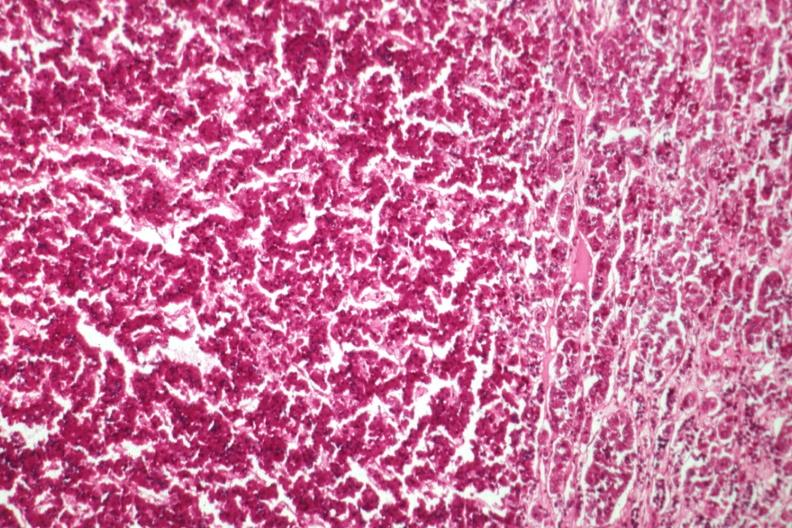what is present?
Answer the question using a single word or phrase. Eosinophilic adenoma 